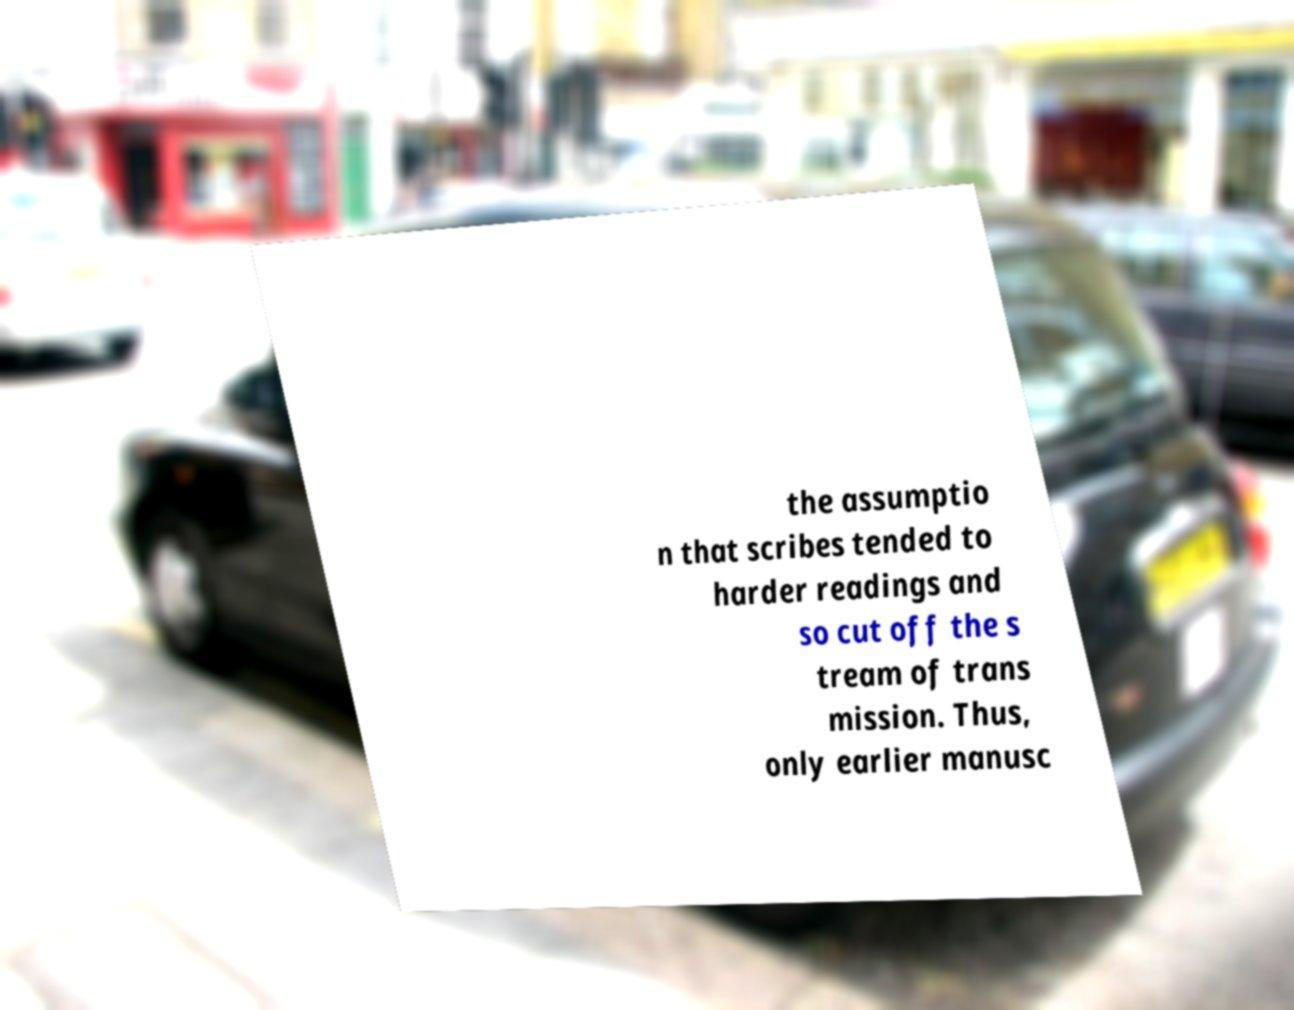Can you read and provide the text displayed in the image?This photo seems to have some interesting text. Can you extract and type it out for me? the assumptio n that scribes tended to harder readings and so cut off the s tream of trans mission. Thus, only earlier manusc 